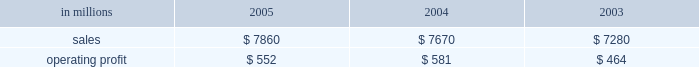Were more than offset by higher raw material and energy costs ( $ 312 million ) , increased market related downtime ( $ 187 million ) and other items ( $ 30 million ) .
Com- pared with 2003 , higher 2005 earnings in the brazilian papers , u.s .
Coated papers and u.s .
Market pulp busi- nesses were offset by lower earnings in the u.s .
Un- coated papers and the european papers businesses .
The printing papers segment took 995000 tons of downtime in 2005 , including 540000 tons of lack-of-order down- time to align production with customer demand .
This compared with 525000 tons of downtime in 2004 , of which 65000 tons related to lack-of-orders .
Printing papers in millions 2005 2004 2003 .
Uncoated papers sales totaled $ 4.8 billion in 2005 compared with $ 5.0 billion in 2004 and 2003 .
Sales price realizations in the united states averaged 4.4% ( 4.4 % ) higher in 2005 than in 2004 , and 4.6% ( 4.6 % ) higher than 2003 .
Favorable pricing momentum which began in 2004 carried over into the beginning of 2005 .
Demand , however , began to weaken across all grades as the year progressed , resulting in lower price realizations in the second and third quarters .
However , prices stabilized as the year ended .
Total shipments for the year were 7.2% ( 7.2 % ) lower than in 2004 and 4.2% ( 4.2 % ) lower than in 2003 .
To continue matching our productive capacity with customer demand , the business announced the perma- nent closure of three uncoated freesheet machines and took significant lack-of-order downtime during the period .
Demand showed some improvement toward the end of the year , bolstered by the introduction our new line of vision innovation paper products ( vip technologiestm ) , with improved brightness and white- ness .
Mill operations were favorable compared to last year , and the rebuild of the no .
1 machine at the east- over , south carolina mill was completed as planned in the fourth quarter .
However , the favorable impacts of improved mill operations and lower overhead costs were more than offset by record high input costs for energy and wood and higher transportation costs compared to 2004 .
The earnings decline in 2005 compared with 2003 was principally due to lower shipments , higher down- time and increased costs for wood , energy and trans- portation , partially offset by lower overhead costs and favorable mill operations .
Average sales price realizations for our european operations remained relatively stable during 2005 , but averaged 1% ( 1 % ) lower than in 2004 , and 6% ( 6 % ) below 2003 levels .
Sales volumes rose slightly , up 1% ( 1 % ) in 2005 com- pared with 2004 and 5% ( 5 % ) compared to 2003 .
Earnings were lower than in 2004 , reflecting higher wood and energy costs and a compression of margins due to un- favorable foreign currency exchange movements .
Earn- ings were also adversely affected by downtime related to the rebuild of three paper machines during the year .
Coated papers sales in the united states were $ 1.6 bil- lion in 2005 , compared with $ 1.4 billion in 2004 and $ 1.3 billion in 2003 .
The business reported an operating profit in 2005 versus a small operating loss in 2004 .
The earnings improvement was driven by higher average sales prices and improved mill operations .
Price realiza- tions in 2005 averaged 13% ( 13 % ) higher than 2004 .
Higher input costs for raw materials and energy partially offset the benefits from improved prices and operations .
Sales volumes were about 1% ( 1 % ) lower in 2005 versus 2004 .
Market pulp sales from our u.s .
And european facilities totaled $ 757 million in 2005 compared with $ 661 mil- lion and $ 571 million in 2004 and 2003 , respectively .
Operating profits in 2005 were up 86% ( 86 % ) from 2004 .
An operating loss had been reported in 2003 .
Higher aver- age prices and sales volumes , lower overhead costs and improved mill operations in 2005 more than offset in- creases in raw material , energy and chemical costs .
U.s .
Softwood and hardwood pulp prices improved through the 2005 first and second quarters , then declined during the third quarter , but recovered somewhat toward year end .
Softwood pulp prices ended the year about 2% ( 2 % ) lower than 2004 , but were 15% ( 15 % ) higher than 2003 , while hardwood pulp prices ended the year about 15% ( 15 % ) higher than 2004 and 10% ( 10 % ) higher than 2003 .
U.s .
Pulp sales volumes were 12% ( 12 % ) higher than in 2004 and 19% ( 19 % ) higher than in 2003 , reflecting increased global demand .
Euro- pean pulp volumes increased 15% ( 15 % ) and 2% ( 2 % ) compared with 2004 and 2003 , respectively , while average sales prices increased 4% ( 4 % ) and 11% ( 11 % ) compared with 2004 and 2003 , respectively .
Brazilian paper sales were $ 684 million in 2005 com- pared with $ 592 million in 2004 and $ 540 million in 2003 .
Sales volumes for uncoated freesheet paper , coated paper and wood chips were down from 2004 , but average price realizations improved for exported un- coated freesheet and coated groundwood paper grades .
Favorable currency translation , as yearly average real exchange rates versus the u.s .
Dollar were 17% ( 17 % ) higher in 2005 than in 2004 , positively impacted reported sales in u.s .
Dollars .
Average sales prices for domestic un- coated paper declined 4% ( 4 % ) in local currency versus 2004 , while domestic coated paper prices were down 3% ( 3 % ) .
Operating profits in 2005 were down 9% ( 9 % ) from 2004 , but were up 2% ( 2 % ) from 2003 .
Earnings in 2005 were neg- atively impacted by a weaker product and geographic sales mix for both uncoated and coated papers , reflecting increased competition and softer demand , particularly in the printing , commercial and editorial market segments. .
What was the percent of the increase in the sales of uncoated papers from 2004 to 2005 in billions? 
Computations: (4.8 - 5.0)
Answer: -0.2. 